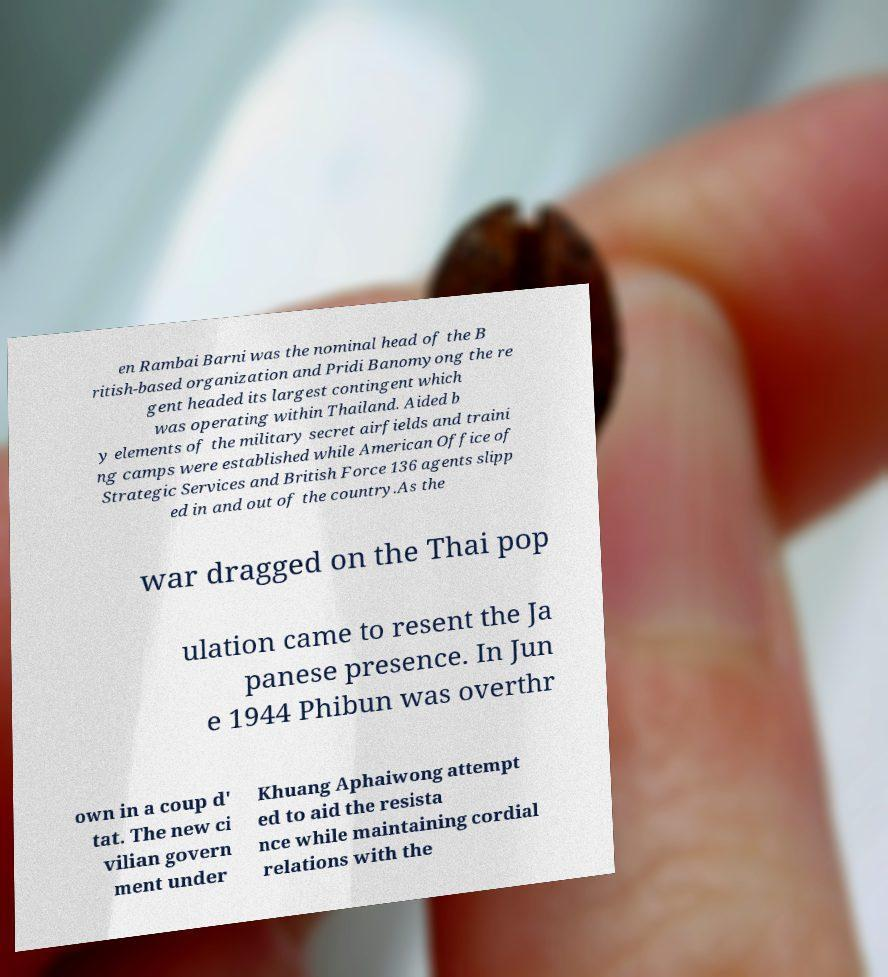There's text embedded in this image that I need extracted. Can you transcribe it verbatim? en Rambai Barni was the nominal head of the B ritish-based organization and Pridi Banomyong the re gent headed its largest contingent which was operating within Thailand. Aided b y elements of the military secret airfields and traini ng camps were established while American Office of Strategic Services and British Force 136 agents slipp ed in and out of the country.As the war dragged on the Thai pop ulation came to resent the Ja panese presence. In Jun e 1944 Phibun was overthr own in a coup d' tat. The new ci vilian govern ment under Khuang Aphaiwong attempt ed to aid the resista nce while maintaining cordial relations with the 